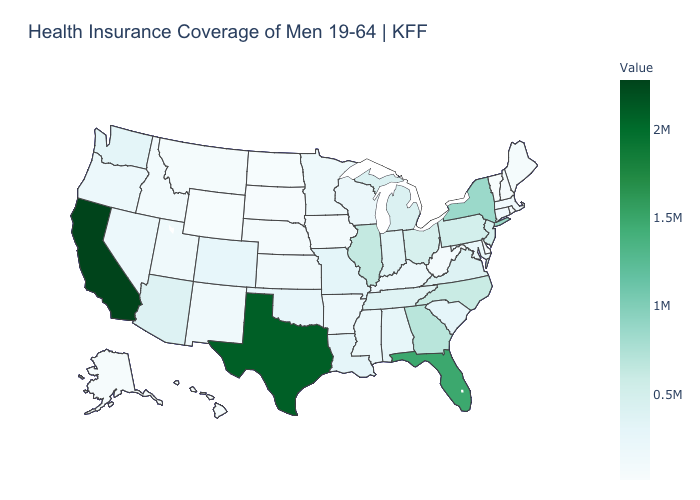Is the legend a continuous bar?
Be succinct. Yes. Does California have the highest value in the USA?
Answer briefly. Yes. Does Illinois have the highest value in the MidWest?
Keep it brief. Yes. Does South Carolina have the highest value in the South?
Concise answer only. No. Which states have the lowest value in the USA?
Short answer required. Vermont. Among the states that border North Dakota , which have the highest value?
Answer briefly. Minnesota. Which states have the lowest value in the West?
Answer briefly. Hawaii. Does California have the highest value in the USA?
Concise answer only. Yes. Which states have the lowest value in the USA?
Short answer required. Vermont. 